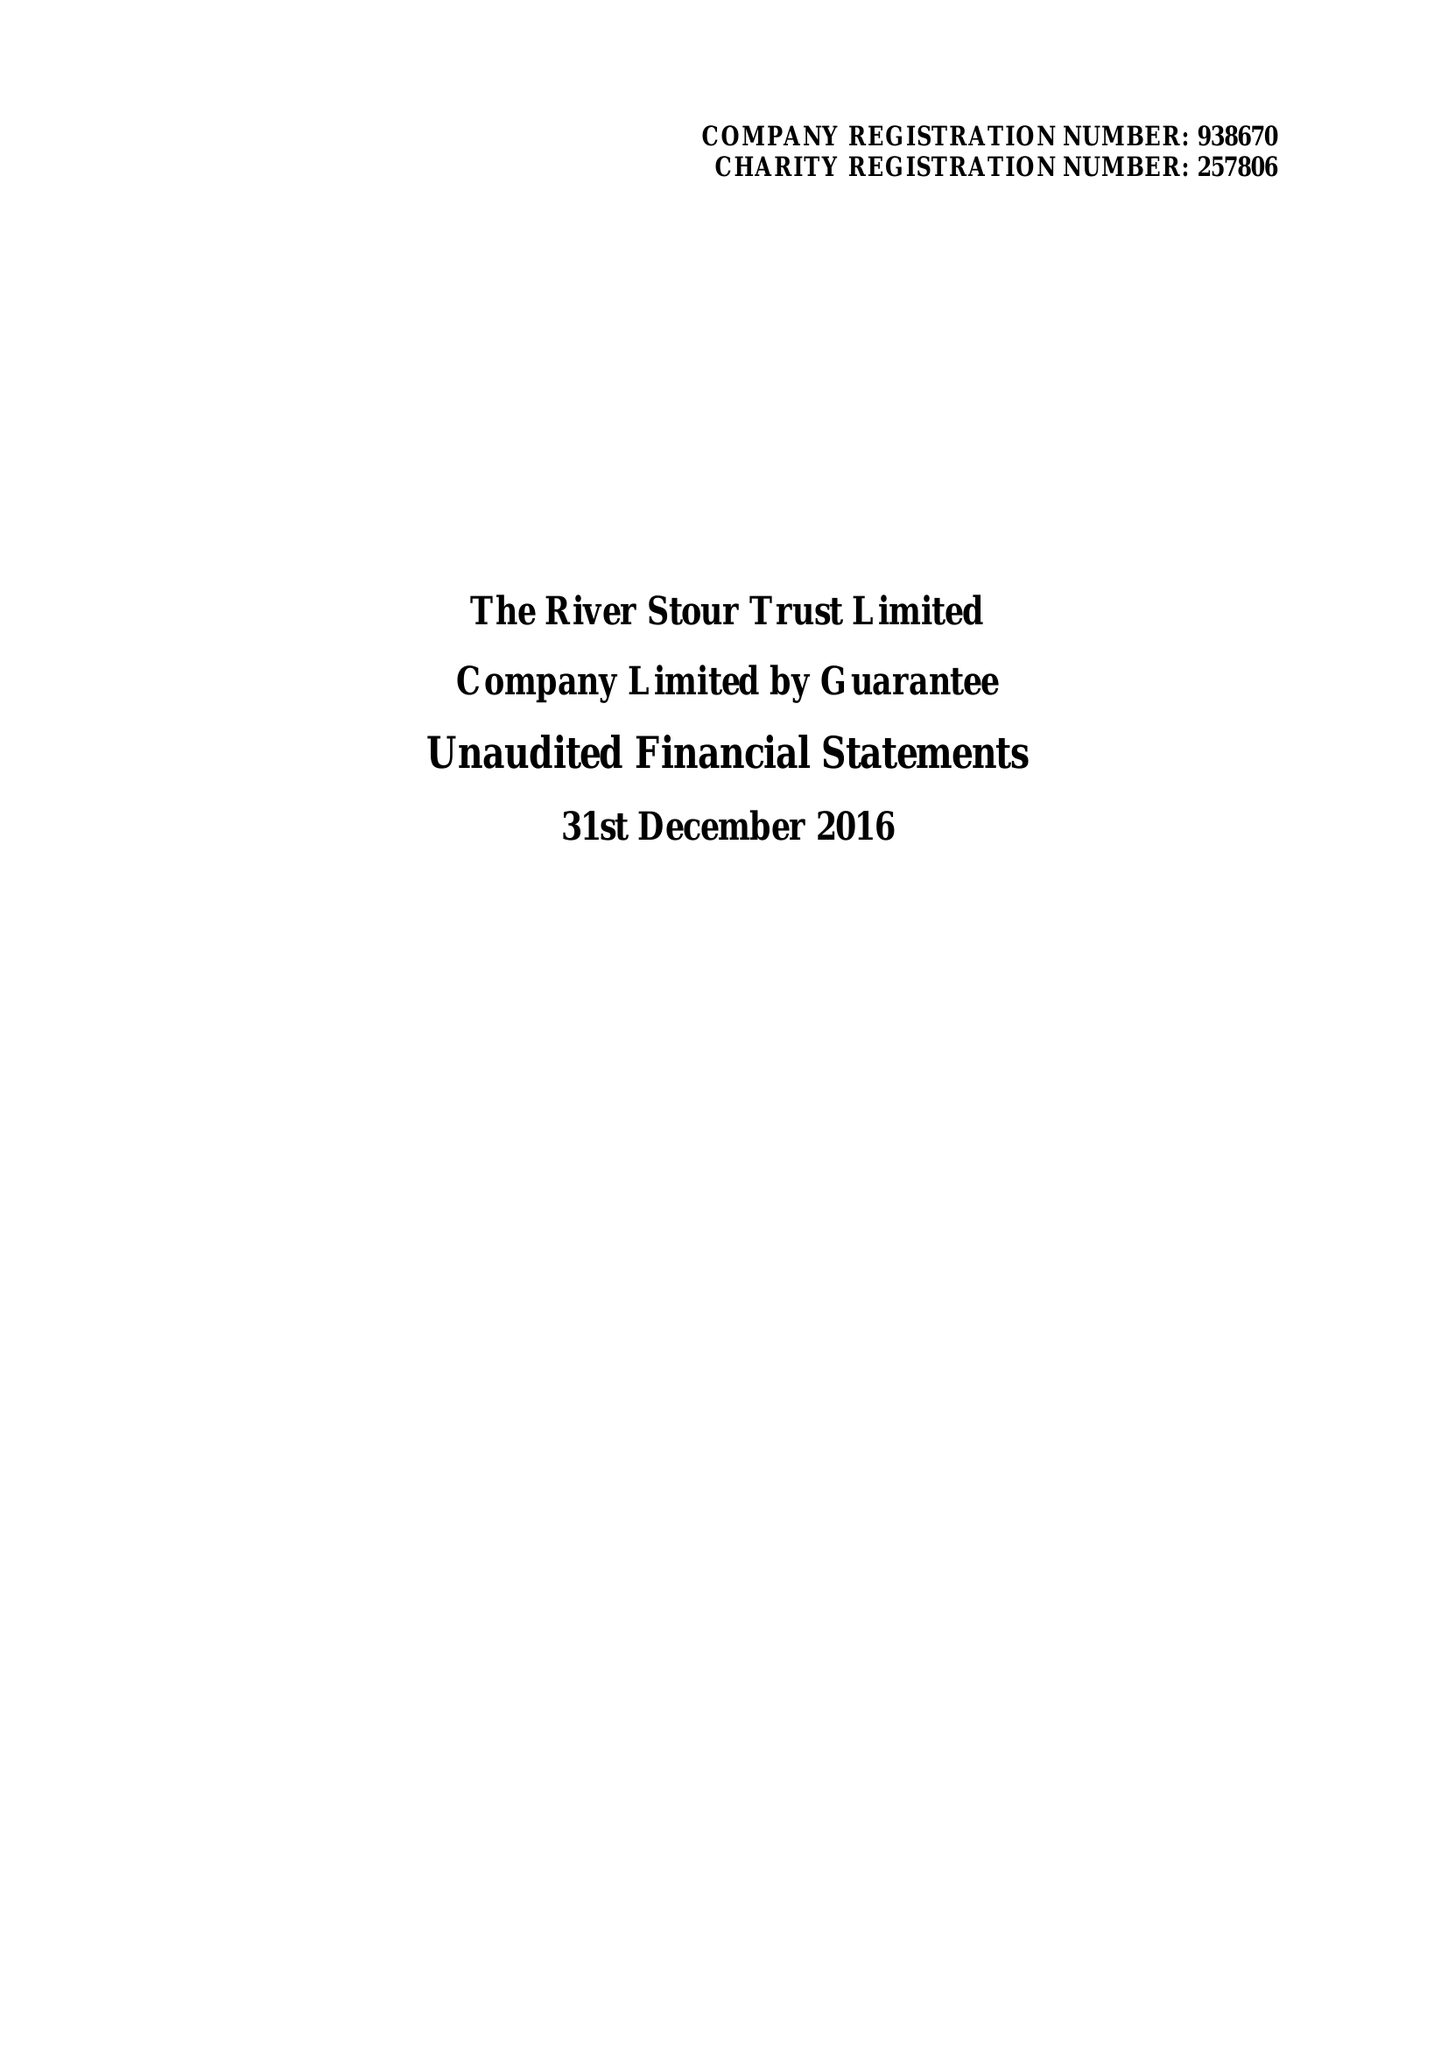What is the value for the charity_name?
Answer the question using a single word or phrase. The River Stour Trust Ltd. 